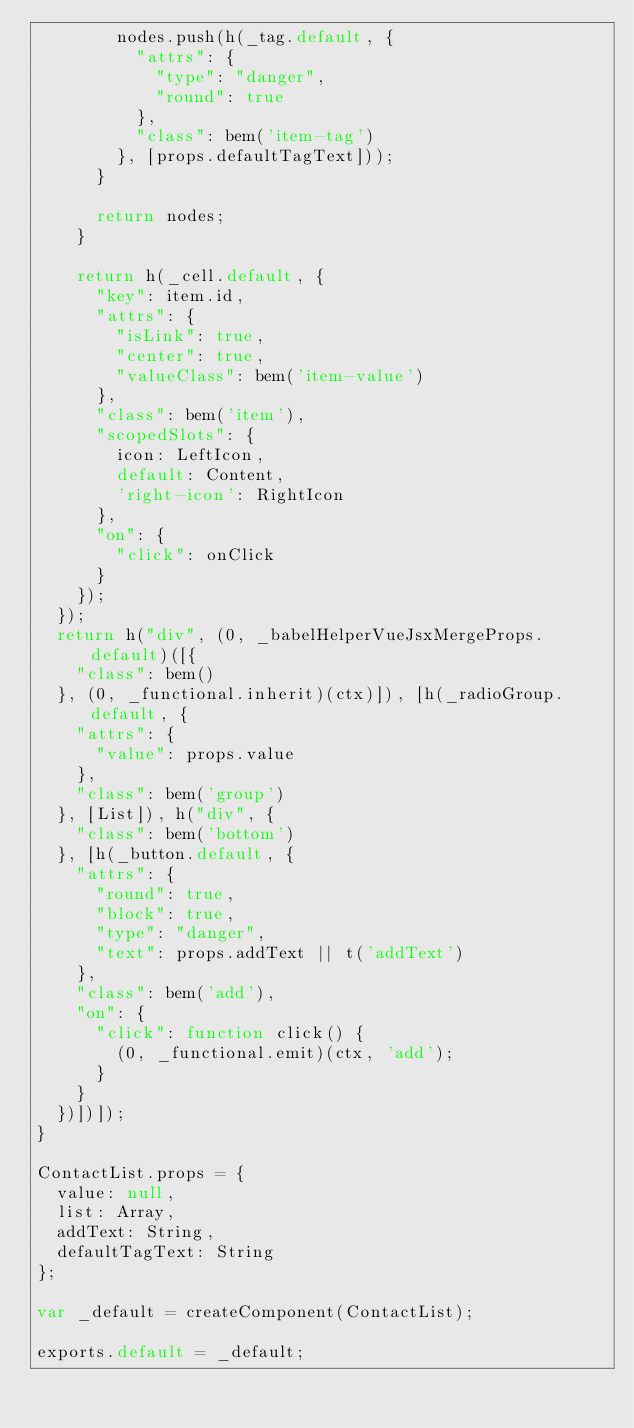Convert code to text. <code><loc_0><loc_0><loc_500><loc_500><_JavaScript_>        nodes.push(h(_tag.default, {
          "attrs": {
            "type": "danger",
            "round": true
          },
          "class": bem('item-tag')
        }, [props.defaultTagText]));
      }

      return nodes;
    }

    return h(_cell.default, {
      "key": item.id,
      "attrs": {
        "isLink": true,
        "center": true,
        "valueClass": bem('item-value')
      },
      "class": bem('item'),
      "scopedSlots": {
        icon: LeftIcon,
        default: Content,
        'right-icon': RightIcon
      },
      "on": {
        "click": onClick
      }
    });
  });
  return h("div", (0, _babelHelperVueJsxMergeProps.default)([{
    "class": bem()
  }, (0, _functional.inherit)(ctx)]), [h(_radioGroup.default, {
    "attrs": {
      "value": props.value
    },
    "class": bem('group')
  }, [List]), h("div", {
    "class": bem('bottom')
  }, [h(_button.default, {
    "attrs": {
      "round": true,
      "block": true,
      "type": "danger",
      "text": props.addText || t('addText')
    },
    "class": bem('add'),
    "on": {
      "click": function click() {
        (0, _functional.emit)(ctx, 'add');
      }
    }
  })])]);
}

ContactList.props = {
  value: null,
  list: Array,
  addText: String,
  defaultTagText: String
};

var _default = createComponent(ContactList);

exports.default = _default;</code> 